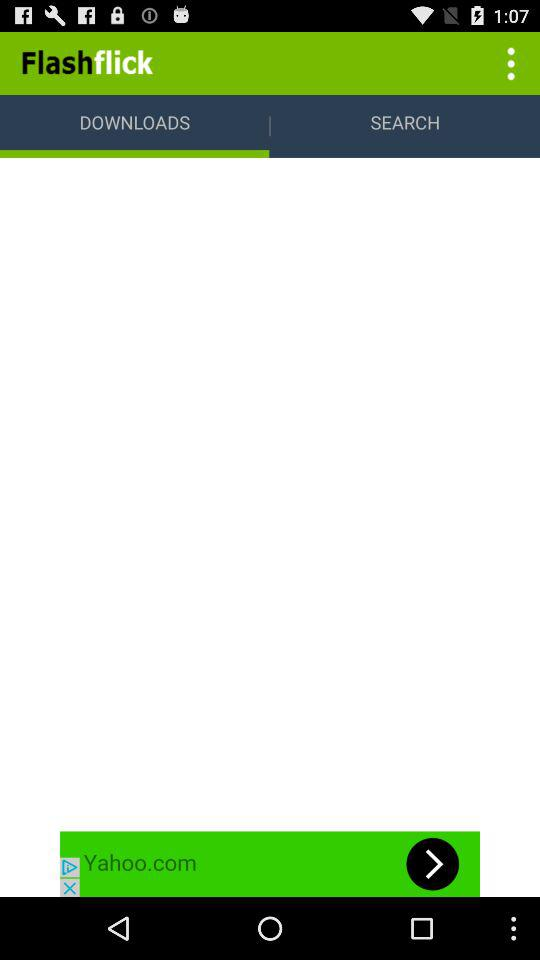What is the application name? The application name is Flashflick. 